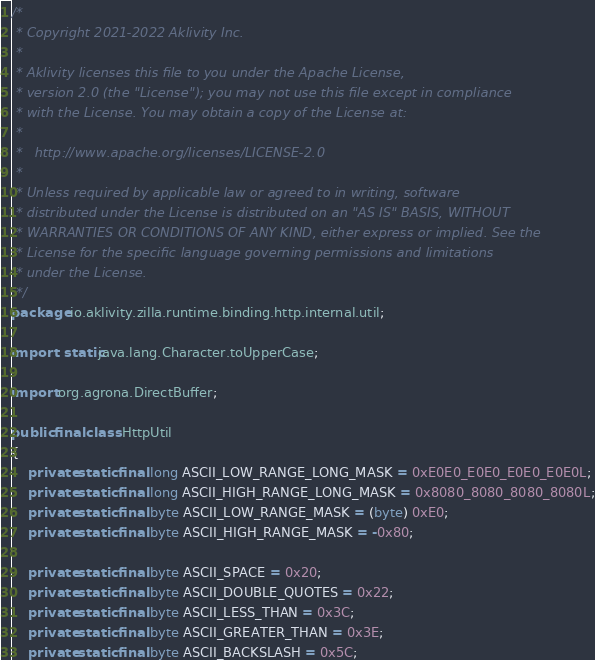<code> <loc_0><loc_0><loc_500><loc_500><_Java_>/*
 * Copyright 2021-2022 Aklivity Inc.
 *
 * Aklivity licenses this file to you under the Apache License,
 * version 2.0 (the "License"); you may not use this file except in compliance
 * with the License. You may obtain a copy of the License at:
 *
 *   http://www.apache.org/licenses/LICENSE-2.0
 *
 * Unless required by applicable law or agreed to in writing, software
 * distributed under the License is distributed on an "AS IS" BASIS, WITHOUT
 * WARRANTIES OR CONDITIONS OF ANY KIND, either express or implied. See the
 * License for the specific language governing permissions and limitations
 * under the License.
 */
package io.aklivity.zilla.runtime.binding.http.internal.util;

import static java.lang.Character.toUpperCase;

import org.agrona.DirectBuffer;

public final class HttpUtil
{
    private static final long ASCII_LOW_RANGE_LONG_MASK = 0xE0E0_E0E0_E0E0_E0E0L;
    private static final long ASCII_HIGH_RANGE_LONG_MASK = 0x8080_8080_8080_8080L;
    private static final byte ASCII_LOW_RANGE_MASK = (byte) 0xE0;
    private static final byte ASCII_HIGH_RANGE_MASK = -0x80;

    private static final byte ASCII_SPACE = 0x20;
    private static final byte ASCII_DOUBLE_QUOTES = 0x22;
    private static final byte ASCII_LESS_THAN = 0x3C;
    private static final byte ASCII_GREATER_THAN = 0x3E;
    private static final byte ASCII_BACKSLASH = 0x5C;</code> 